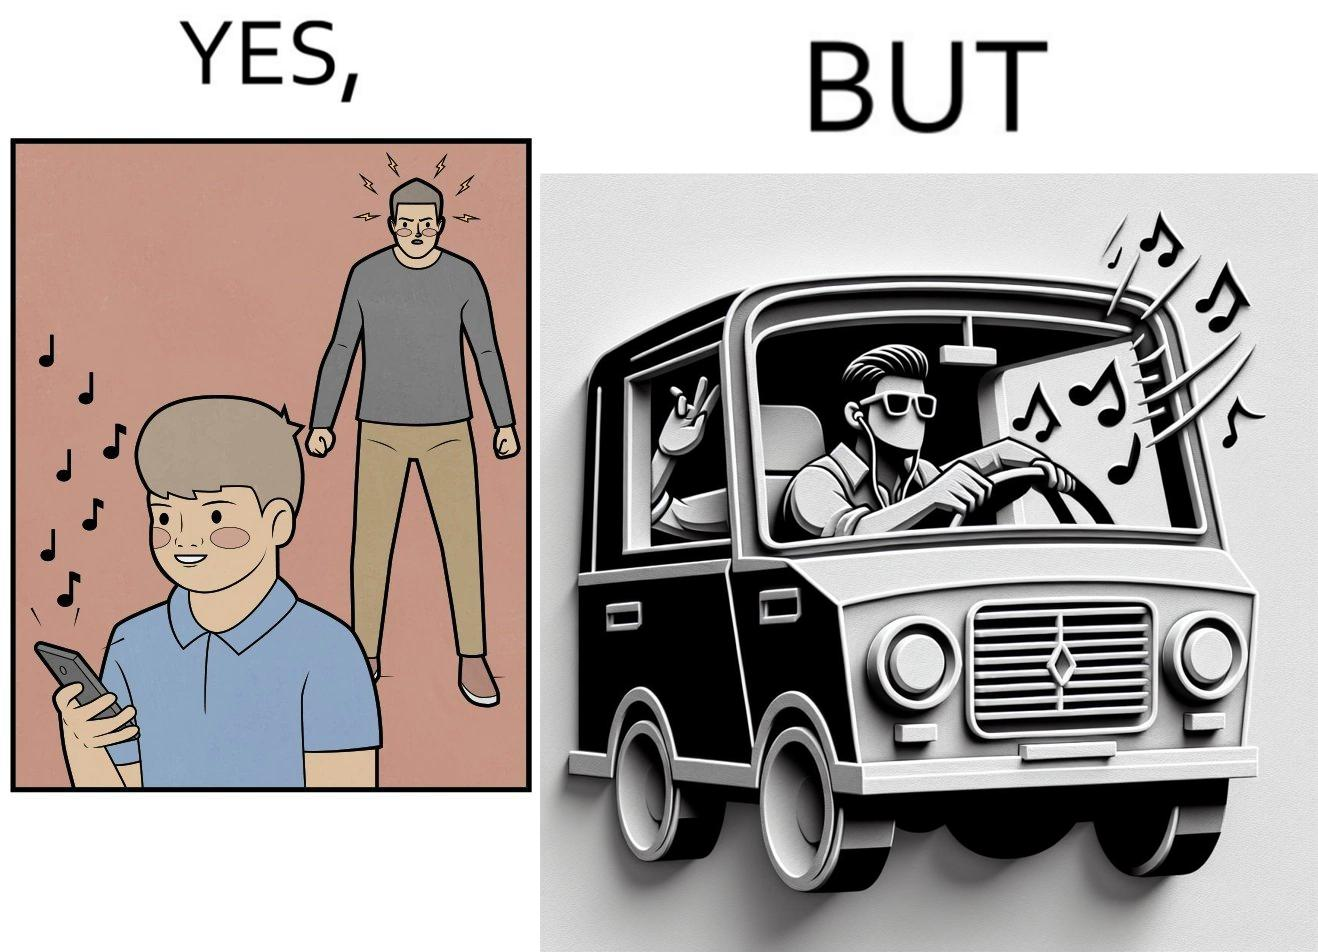What do you see in each half of this image? In the left part of the image: The image shows a boy playing music on his phone loudly. The image also shows another man annoyed by the loud music. In the right part of the image: The image shows a man driving a car with the windows of the car rolled down. He has one of his hands on the steering wheel and the other hand hanging out of the window of the driver side of the car. The man is playing loud music in his car with the sound coming out of the car. 